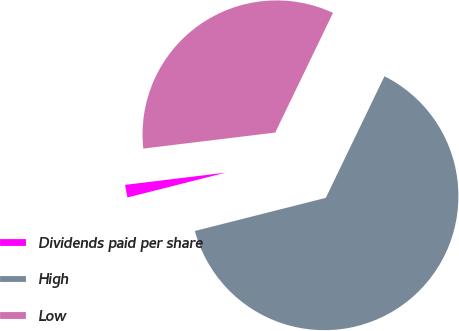<chart> <loc_0><loc_0><loc_500><loc_500><pie_chart><fcel>Dividends paid per share<fcel>High<fcel>Low<nl><fcel>2.02%<fcel>63.9%<fcel>34.08%<nl></chart> 